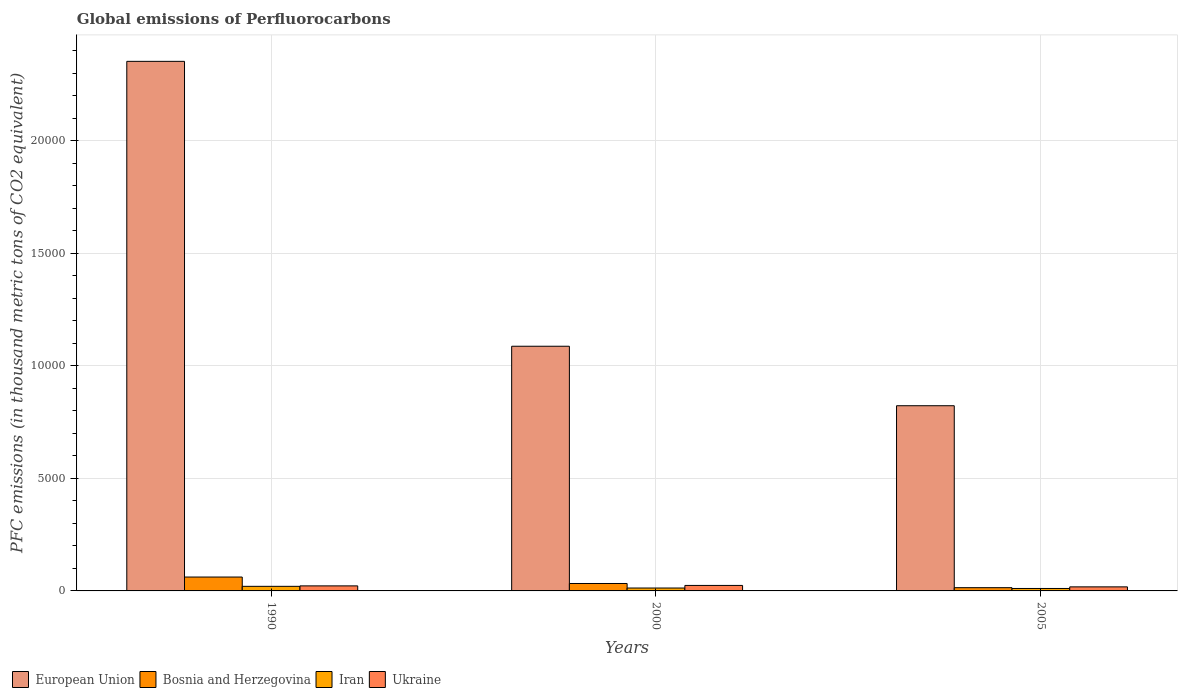How many groups of bars are there?
Give a very brief answer. 3. Are the number of bars per tick equal to the number of legend labels?
Give a very brief answer. Yes. How many bars are there on the 2nd tick from the right?
Make the answer very short. 4. What is the label of the 2nd group of bars from the left?
Offer a terse response. 2000. In how many cases, is the number of bars for a given year not equal to the number of legend labels?
Make the answer very short. 0. What is the global emissions of Perfluorocarbons in Ukraine in 2000?
Your answer should be very brief. 244.1. Across all years, what is the maximum global emissions of Perfluorocarbons in Iran?
Your answer should be compact. 203.5. Across all years, what is the minimum global emissions of Perfluorocarbons in Ukraine?
Your answer should be compact. 180.5. In which year was the global emissions of Perfluorocarbons in Ukraine maximum?
Give a very brief answer. 2000. In which year was the global emissions of Perfluorocarbons in Ukraine minimum?
Keep it short and to the point. 2005. What is the total global emissions of Perfluorocarbons in Bosnia and Herzegovina in the graph?
Your response must be concise. 1091. What is the difference between the global emissions of Perfluorocarbons in Ukraine in 1990 and that in 2000?
Your response must be concise. -20.1. What is the difference between the global emissions of Perfluorocarbons in Ukraine in 2005 and the global emissions of Perfluorocarbons in Bosnia and Herzegovina in 1990?
Offer a terse response. -436.2. What is the average global emissions of Perfluorocarbons in Ukraine per year?
Provide a succinct answer. 216.2. In the year 2005, what is the difference between the global emissions of Perfluorocarbons in Bosnia and Herzegovina and global emissions of Perfluorocarbons in Ukraine?
Keep it short and to the point. -36.1. What is the ratio of the global emissions of Perfluorocarbons in Bosnia and Herzegovina in 1990 to that in 2000?
Make the answer very short. 1.87. Is the difference between the global emissions of Perfluorocarbons in Bosnia and Herzegovina in 1990 and 2005 greater than the difference between the global emissions of Perfluorocarbons in Ukraine in 1990 and 2005?
Make the answer very short. Yes. What is the difference between the highest and the second highest global emissions of Perfluorocarbons in European Union?
Provide a short and direct response. 1.27e+04. What is the difference between the highest and the lowest global emissions of Perfluorocarbons in Iran?
Give a very brief answer. 95. Is it the case that in every year, the sum of the global emissions of Perfluorocarbons in Iran and global emissions of Perfluorocarbons in European Union is greater than the sum of global emissions of Perfluorocarbons in Ukraine and global emissions of Perfluorocarbons in Bosnia and Herzegovina?
Provide a succinct answer. Yes. What does the 2nd bar from the left in 2005 represents?
Provide a succinct answer. Bosnia and Herzegovina. What does the 2nd bar from the right in 2005 represents?
Your response must be concise. Iran. Is it the case that in every year, the sum of the global emissions of Perfluorocarbons in Bosnia and Herzegovina and global emissions of Perfluorocarbons in Ukraine is greater than the global emissions of Perfluorocarbons in Iran?
Your answer should be compact. Yes. Are the values on the major ticks of Y-axis written in scientific E-notation?
Your answer should be very brief. No. Does the graph contain any zero values?
Keep it short and to the point. No. Where does the legend appear in the graph?
Your response must be concise. Bottom left. How many legend labels are there?
Make the answer very short. 4. What is the title of the graph?
Your answer should be compact. Global emissions of Perfluorocarbons. What is the label or title of the X-axis?
Your answer should be very brief. Years. What is the label or title of the Y-axis?
Give a very brief answer. PFC emissions (in thousand metric tons of CO2 equivalent). What is the PFC emissions (in thousand metric tons of CO2 equivalent) of European Union in 1990?
Provide a succinct answer. 2.35e+04. What is the PFC emissions (in thousand metric tons of CO2 equivalent) of Bosnia and Herzegovina in 1990?
Your answer should be compact. 616.7. What is the PFC emissions (in thousand metric tons of CO2 equivalent) of Iran in 1990?
Give a very brief answer. 203.5. What is the PFC emissions (in thousand metric tons of CO2 equivalent) of Ukraine in 1990?
Offer a very short reply. 224. What is the PFC emissions (in thousand metric tons of CO2 equivalent) of European Union in 2000?
Your response must be concise. 1.09e+04. What is the PFC emissions (in thousand metric tons of CO2 equivalent) in Bosnia and Herzegovina in 2000?
Ensure brevity in your answer.  329.9. What is the PFC emissions (in thousand metric tons of CO2 equivalent) in Iran in 2000?
Ensure brevity in your answer.  128.5. What is the PFC emissions (in thousand metric tons of CO2 equivalent) in Ukraine in 2000?
Ensure brevity in your answer.  244.1. What is the PFC emissions (in thousand metric tons of CO2 equivalent) in European Union in 2005?
Your answer should be compact. 8230.79. What is the PFC emissions (in thousand metric tons of CO2 equivalent) of Bosnia and Herzegovina in 2005?
Offer a very short reply. 144.4. What is the PFC emissions (in thousand metric tons of CO2 equivalent) in Iran in 2005?
Your response must be concise. 108.5. What is the PFC emissions (in thousand metric tons of CO2 equivalent) in Ukraine in 2005?
Make the answer very short. 180.5. Across all years, what is the maximum PFC emissions (in thousand metric tons of CO2 equivalent) in European Union?
Offer a terse response. 2.35e+04. Across all years, what is the maximum PFC emissions (in thousand metric tons of CO2 equivalent) in Bosnia and Herzegovina?
Make the answer very short. 616.7. Across all years, what is the maximum PFC emissions (in thousand metric tons of CO2 equivalent) in Iran?
Your answer should be very brief. 203.5. Across all years, what is the maximum PFC emissions (in thousand metric tons of CO2 equivalent) in Ukraine?
Provide a short and direct response. 244.1. Across all years, what is the minimum PFC emissions (in thousand metric tons of CO2 equivalent) of European Union?
Your response must be concise. 8230.79. Across all years, what is the minimum PFC emissions (in thousand metric tons of CO2 equivalent) in Bosnia and Herzegovina?
Your answer should be compact. 144.4. Across all years, what is the minimum PFC emissions (in thousand metric tons of CO2 equivalent) in Iran?
Make the answer very short. 108.5. Across all years, what is the minimum PFC emissions (in thousand metric tons of CO2 equivalent) of Ukraine?
Your answer should be compact. 180.5. What is the total PFC emissions (in thousand metric tons of CO2 equivalent) in European Union in the graph?
Provide a succinct answer. 4.26e+04. What is the total PFC emissions (in thousand metric tons of CO2 equivalent) in Bosnia and Herzegovina in the graph?
Ensure brevity in your answer.  1091. What is the total PFC emissions (in thousand metric tons of CO2 equivalent) in Iran in the graph?
Ensure brevity in your answer.  440.5. What is the total PFC emissions (in thousand metric tons of CO2 equivalent) in Ukraine in the graph?
Provide a short and direct response. 648.6. What is the difference between the PFC emissions (in thousand metric tons of CO2 equivalent) of European Union in 1990 and that in 2000?
Offer a terse response. 1.27e+04. What is the difference between the PFC emissions (in thousand metric tons of CO2 equivalent) in Bosnia and Herzegovina in 1990 and that in 2000?
Provide a succinct answer. 286.8. What is the difference between the PFC emissions (in thousand metric tons of CO2 equivalent) of Iran in 1990 and that in 2000?
Ensure brevity in your answer.  75. What is the difference between the PFC emissions (in thousand metric tons of CO2 equivalent) in Ukraine in 1990 and that in 2000?
Your response must be concise. -20.1. What is the difference between the PFC emissions (in thousand metric tons of CO2 equivalent) of European Union in 1990 and that in 2005?
Give a very brief answer. 1.53e+04. What is the difference between the PFC emissions (in thousand metric tons of CO2 equivalent) in Bosnia and Herzegovina in 1990 and that in 2005?
Offer a very short reply. 472.3. What is the difference between the PFC emissions (in thousand metric tons of CO2 equivalent) in Ukraine in 1990 and that in 2005?
Make the answer very short. 43.5. What is the difference between the PFC emissions (in thousand metric tons of CO2 equivalent) in European Union in 2000 and that in 2005?
Keep it short and to the point. 2643.81. What is the difference between the PFC emissions (in thousand metric tons of CO2 equivalent) in Bosnia and Herzegovina in 2000 and that in 2005?
Provide a short and direct response. 185.5. What is the difference between the PFC emissions (in thousand metric tons of CO2 equivalent) of Ukraine in 2000 and that in 2005?
Give a very brief answer. 63.6. What is the difference between the PFC emissions (in thousand metric tons of CO2 equivalent) of European Union in 1990 and the PFC emissions (in thousand metric tons of CO2 equivalent) of Bosnia and Herzegovina in 2000?
Give a very brief answer. 2.32e+04. What is the difference between the PFC emissions (in thousand metric tons of CO2 equivalent) of European Union in 1990 and the PFC emissions (in thousand metric tons of CO2 equivalent) of Iran in 2000?
Give a very brief answer. 2.34e+04. What is the difference between the PFC emissions (in thousand metric tons of CO2 equivalent) in European Union in 1990 and the PFC emissions (in thousand metric tons of CO2 equivalent) in Ukraine in 2000?
Offer a very short reply. 2.33e+04. What is the difference between the PFC emissions (in thousand metric tons of CO2 equivalent) of Bosnia and Herzegovina in 1990 and the PFC emissions (in thousand metric tons of CO2 equivalent) of Iran in 2000?
Make the answer very short. 488.2. What is the difference between the PFC emissions (in thousand metric tons of CO2 equivalent) in Bosnia and Herzegovina in 1990 and the PFC emissions (in thousand metric tons of CO2 equivalent) in Ukraine in 2000?
Ensure brevity in your answer.  372.6. What is the difference between the PFC emissions (in thousand metric tons of CO2 equivalent) in Iran in 1990 and the PFC emissions (in thousand metric tons of CO2 equivalent) in Ukraine in 2000?
Provide a short and direct response. -40.6. What is the difference between the PFC emissions (in thousand metric tons of CO2 equivalent) in European Union in 1990 and the PFC emissions (in thousand metric tons of CO2 equivalent) in Bosnia and Herzegovina in 2005?
Offer a terse response. 2.34e+04. What is the difference between the PFC emissions (in thousand metric tons of CO2 equivalent) in European Union in 1990 and the PFC emissions (in thousand metric tons of CO2 equivalent) in Iran in 2005?
Your response must be concise. 2.34e+04. What is the difference between the PFC emissions (in thousand metric tons of CO2 equivalent) in European Union in 1990 and the PFC emissions (in thousand metric tons of CO2 equivalent) in Ukraine in 2005?
Ensure brevity in your answer.  2.34e+04. What is the difference between the PFC emissions (in thousand metric tons of CO2 equivalent) of Bosnia and Herzegovina in 1990 and the PFC emissions (in thousand metric tons of CO2 equivalent) of Iran in 2005?
Offer a very short reply. 508.2. What is the difference between the PFC emissions (in thousand metric tons of CO2 equivalent) of Bosnia and Herzegovina in 1990 and the PFC emissions (in thousand metric tons of CO2 equivalent) of Ukraine in 2005?
Keep it short and to the point. 436.2. What is the difference between the PFC emissions (in thousand metric tons of CO2 equivalent) of Iran in 1990 and the PFC emissions (in thousand metric tons of CO2 equivalent) of Ukraine in 2005?
Your answer should be compact. 23. What is the difference between the PFC emissions (in thousand metric tons of CO2 equivalent) of European Union in 2000 and the PFC emissions (in thousand metric tons of CO2 equivalent) of Bosnia and Herzegovina in 2005?
Ensure brevity in your answer.  1.07e+04. What is the difference between the PFC emissions (in thousand metric tons of CO2 equivalent) of European Union in 2000 and the PFC emissions (in thousand metric tons of CO2 equivalent) of Iran in 2005?
Your response must be concise. 1.08e+04. What is the difference between the PFC emissions (in thousand metric tons of CO2 equivalent) in European Union in 2000 and the PFC emissions (in thousand metric tons of CO2 equivalent) in Ukraine in 2005?
Your response must be concise. 1.07e+04. What is the difference between the PFC emissions (in thousand metric tons of CO2 equivalent) in Bosnia and Herzegovina in 2000 and the PFC emissions (in thousand metric tons of CO2 equivalent) in Iran in 2005?
Provide a succinct answer. 221.4. What is the difference between the PFC emissions (in thousand metric tons of CO2 equivalent) of Bosnia and Herzegovina in 2000 and the PFC emissions (in thousand metric tons of CO2 equivalent) of Ukraine in 2005?
Your answer should be very brief. 149.4. What is the difference between the PFC emissions (in thousand metric tons of CO2 equivalent) in Iran in 2000 and the PFC emissions (in thousand metric tons of CO2 equivalent) in Ukraine in 2005?
Offer a terse response. -52. What is the average PFC emissions (in thousand metric tons of CO2 equivalent) of European Union per year?
Your answer should be compact. 1.42e+04. What is the average PFC emissions (in thousand metric tons of CO2 equivalent) of Bosnia and Herzegovina per year?
Ensure brevity in your answer.  363.67. What is the average PFC emissions (in thousand metric tons of CO2 equivalent) of Iran per year?
Make the answer very short. 146.83. What is the average PFC emissions (in thousand metric tons of CO2 equivalent) in Ukraine per year?
Provide a succinct answer. 216.2. In the year 1990, what is the difference between the PFC emissions (in thousand metric tons of CO2 equivalent) in European Union and PFC emissions (in thousand metric tons of CO2 equivalent) in Bosnia and Herzegovina?
Your answer should be very brief. 2.29e+04. In the year 1990, what is the difference between the PFC emissions (in thousand metric tons of CO2 equivalent) in European Union and PFC emissions (in thousand metric tons of CO2 equivalent) in Iran?
Your answer should be very brief. 2.33e+04. In the year 1990, what is the difference between the PFC emissions (in thousand metric tons of CO2 equivalent) in European Union and PFC emissions (in thousand metric tons of CO2 equivalent) in Ukraine?
Your answer should be compact. 2.33e+04. In the year 1990, what is the difference between the PFC emissions (in thousand metric tons of CO2 equivalent) of Bosnia and Herzegovina and PFC emissions (in thousand metric tons of CO2 equivalent) of Iran?
Your answer should be very brief. 413.2. In the year 1990, what is the difference between the PFC emissions (in thousand metric tons of CO2 equivalent) in Bosnia and Herzegovina and PFC emissions (in thousand metric tons of CO2 equivalent) in Ukraine?
Your answer should be compact. 392.7. In the year 1990, what is the difference between the PFC emissions (in thousand metric tons of CO2 equivalent) in Iran and PFC emissions (in thousand metric tons of CO2 equivalent) in Ukraine?
Ensure brevity in your answer.  -20.5. In the year 2000, what is the difference between the PFC emissions (in thousand metric tons of CO2 equivalent) of European Union and PFC emissions (in thousand metric tons of CO2 equivalent) of Bosnia and Herzegovina?
Ensure brevity in your answer.  1.05e+04. In the year 2000, what is the difference between the PFC emissions (in thousand metric tons of CO2 equivalent) of European Union and PFC emissions (in thousand metric tons of CO2 equivalent) of Iran?
Offer a terse response. 1.07e+04. In the year 2000, what is the difference between the PFC emissions (in thousand metric tons of CO2 equivalent) in European Union and PFC emissions (in thousand metric tons of CO2 equivalent) in Ukraine?
Ensure brevity in your answer.  1.06e+04. In the year 2000, what is the difference between the PFC emissions (in thousand metric tons of CO2 equivalent) of Bosnia and Herzegovina and PFC emissions (in thousand metric tons of CO2 equivalent) of Iran?
Your answer should be very brief. 201.4. In the year 2000, what is the difference between the PFC emissions (in thousand metric tons of CO2 equivalent) of Bosnia and Herzegovina and PFC emissions (in thousand metric tons of CO2 equivalent) of Ukraine?
Offer a very short reply. 85.8. In the year 2000, what is the difference between the PFC emissions (in thousand metric tons of CO2 equivalent) in Iran and PFC emissions (in thousand metric tons of CO2 equivalent) in Ukraine?
Make the answer very short. -115.6. In the year 2005, what is the difference between the PFC emissions (in thousand metric tons of CO2 equivalent) of European Union and PFC emissions (in thousand metric tons of CO2 equivalent) of Bosnia and Herzegovina?
Provide a short and direct response. 8086.39. In the year 2005, what is the difference between the PFC emissions (in thousand metric tons of CO2 equivalent) in European Union and PFC emissions (in thousand metric tons of CO2 equivalent) in Iran?
Keep it short and to the point. 8122.29. In the year 2005, what is the difference between the PFC emissions (in thousand metric tons of CO2 equivalent) in European Union and PFC emissions (in thousand metric tons of CO2 equivalent) in Ukraine?
Your response must be concise. 8050.29. In the year 2005, what is the difference between the PFC emissions (in thousand metric tons of CO2 equivalent) of Bosnia and Herzegovina and PFC emissions (in thousand metric tons of CO2 equivalent) of Iran?
Give a very brief answer. 35.9. In the year 2005, what is the difference between the PFC emissions (in thousand metric tons of CO2 equivalent) of Bosnia and Herzegovina and PFC emissions (in thousand metric tons of CO2 equivalent) of Ukraine?
Provide a short and direct response. -36.1. In the year 2005, what is the difference between the PFC emissions (in thousand metric tons of CO2 equivalent) of Iran and PFC emissions (in thousand metric tons of CO2 equivalent) of Ukraine?
Give a very brief answer. -72. What is the ratio of the PFC emissions (in thousand metric tons of CO2 equivalent) of European Union in 1990 to that in 2000?
Make the answer very short. 2.16. What is the ratio of the PFC emissions (in thousand metric tons of CO2 equivalent) of Bosnia and Herzegovina in 1990 to that in 2000?
Your answer should be very brief. 1.87. What is the ratio of the PFC emissions (in thousand metric tons of CO2 equivalent) in Iran in 1990 to that in 2000?
Give a very brief answer. 1.58. What is the ratio of the PFC emissions (in thousand metric tons of CO2 equivalent) in Ukraine in 1990 to that in 2000?
Give a very brief answer. 0.92. What is the ratio of the PFC emissions (in thousand metric tons of CO2 equivalent) of European Union in 1990 to that in 2005?
Offer a terse response. 2.86. What is the ratio of the PFC emissions (in thousand metric tons of CO2 equivalent) of Bosnia and Herzegovina in 1990 to that in 2005?
Offer a very short reply. 4.27. What is the ratio of the PFC emissions (in thousand metric tons of CO2 equivalent) of Iran in 1990 to that in 2005?
Provide a succinct answer. 1.88. What is the ratio of the PFC emissions (in thousand metric tons of CO2 equivalent) in Ukraine in 1990 to that in 2005?
Make the answer very short. 1.24. What is the ratio of the PFC emissions (in thousand metric tons of CO2 equivalent) of European Union in 2000 to that in 2005?
Give a very brief answer. 1.32. What is the ratio of the PFC emissions (in thousand metric tons of CO2 equivalent) of Bosnia and Herzegovina in 2000 to that in 2005?
Make the answer very short. 2.28. What is the ratio of the PFC emissions (in thousand metric tons of CO2 equivalent) of Iran in 2000 to that in 2005?
Make the answer very short. 1.18. What is the ratio of the PFC emissions (in thousand metric tons of CO2 equivalent) in Ukraine in 2000 to that in 2005?
Give a very brief answer. 1.35. What is the difference between the highest and the second highest PFC emissions (in thousand metric tons of CO2 equivalent) of European Union?
Offer a terse response. 1.27e+04. What is the difference between the highest and the second highest PFC emissions (in thousand metric tons of CO2 equivalent) of Bosnia and Herzegovina?
Offer a terse response. 286.8. What is the difference between the highest and the second highest PFC emissions (in thousand metric tons of CO2 equivalent) of Iran?
Your answer should be compact. 75. What is the difference between the highest and the second highest PFC emissions (in thousand metric tons of CO2 equivalent) of Ukraine?
Your answer should be very brief. 20.1. What is the difference between the highest and the lowest PFC emissions (in thousand metric tons of CO2 equivalent) in European Union?
Ensure brevity in your answer.  1.53e+04. What is the difference between the highest and the lowest PFC emissions (in thousand metric tons of CO2 equivalent) in Bosnia and Herzegovina?
Your response must be concise. 472.3. What is the difference between the highest and the lowest PFC emissions (in thousand metric tons of CO2 equivalent) of Iran?
Ensure brevity in your answer.  95. What is the difference between the highest and the lowest PFC emissions (in thousand metric tons of CO2 equivalent) of Ukraine?
Keep it short and to the point. 63.6. 